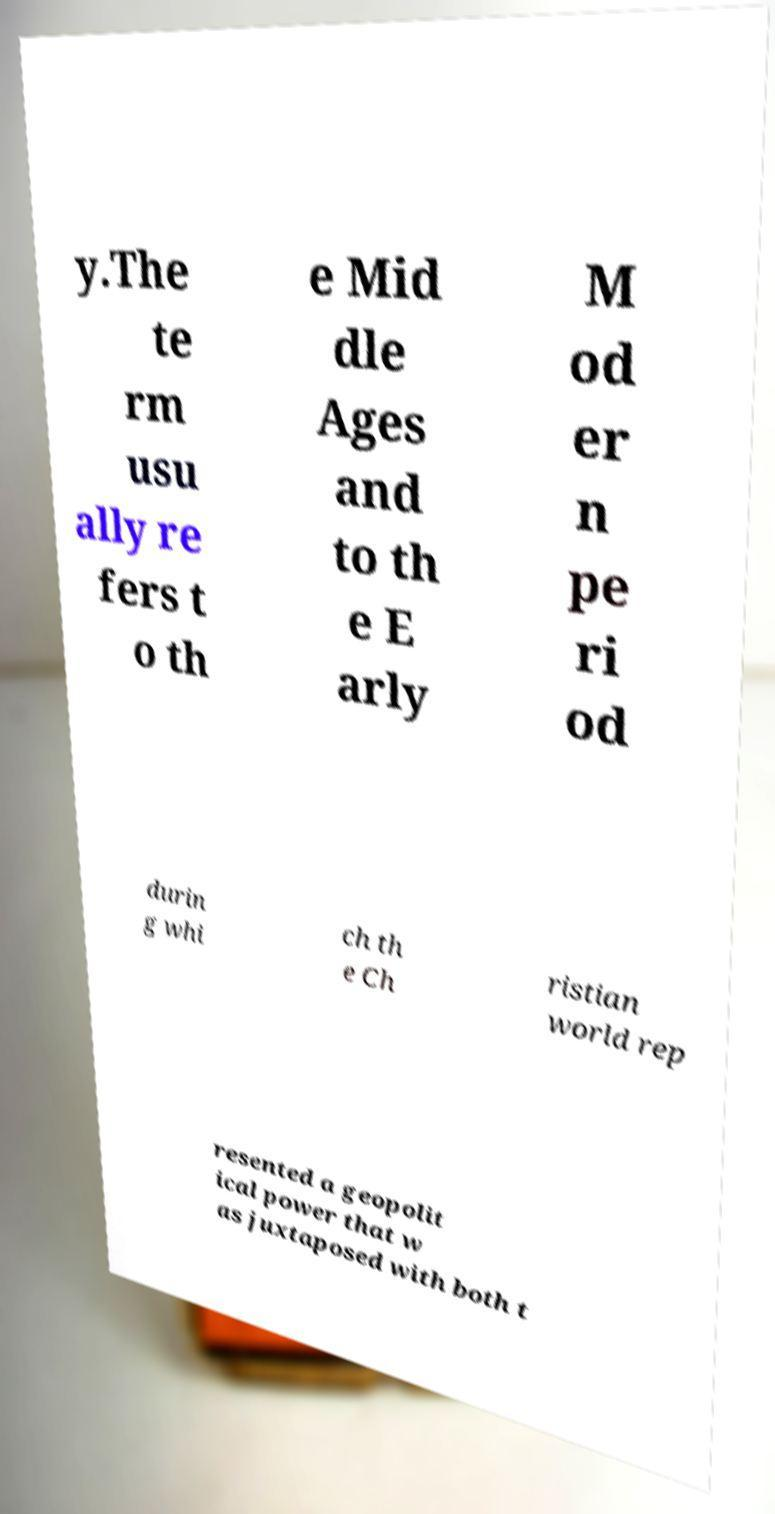Can you read and provide the text displayed in the image?This photo seems to have some interesting text. Can you extract and type it out for me? y.The te rm usu ally re fers t o th e Mid dle Ages and to th e E arly M od er n pe ri od durin g whi ch th e Ch ristian world rep resented a geopolit ical power that w as juxtaposed with both t 